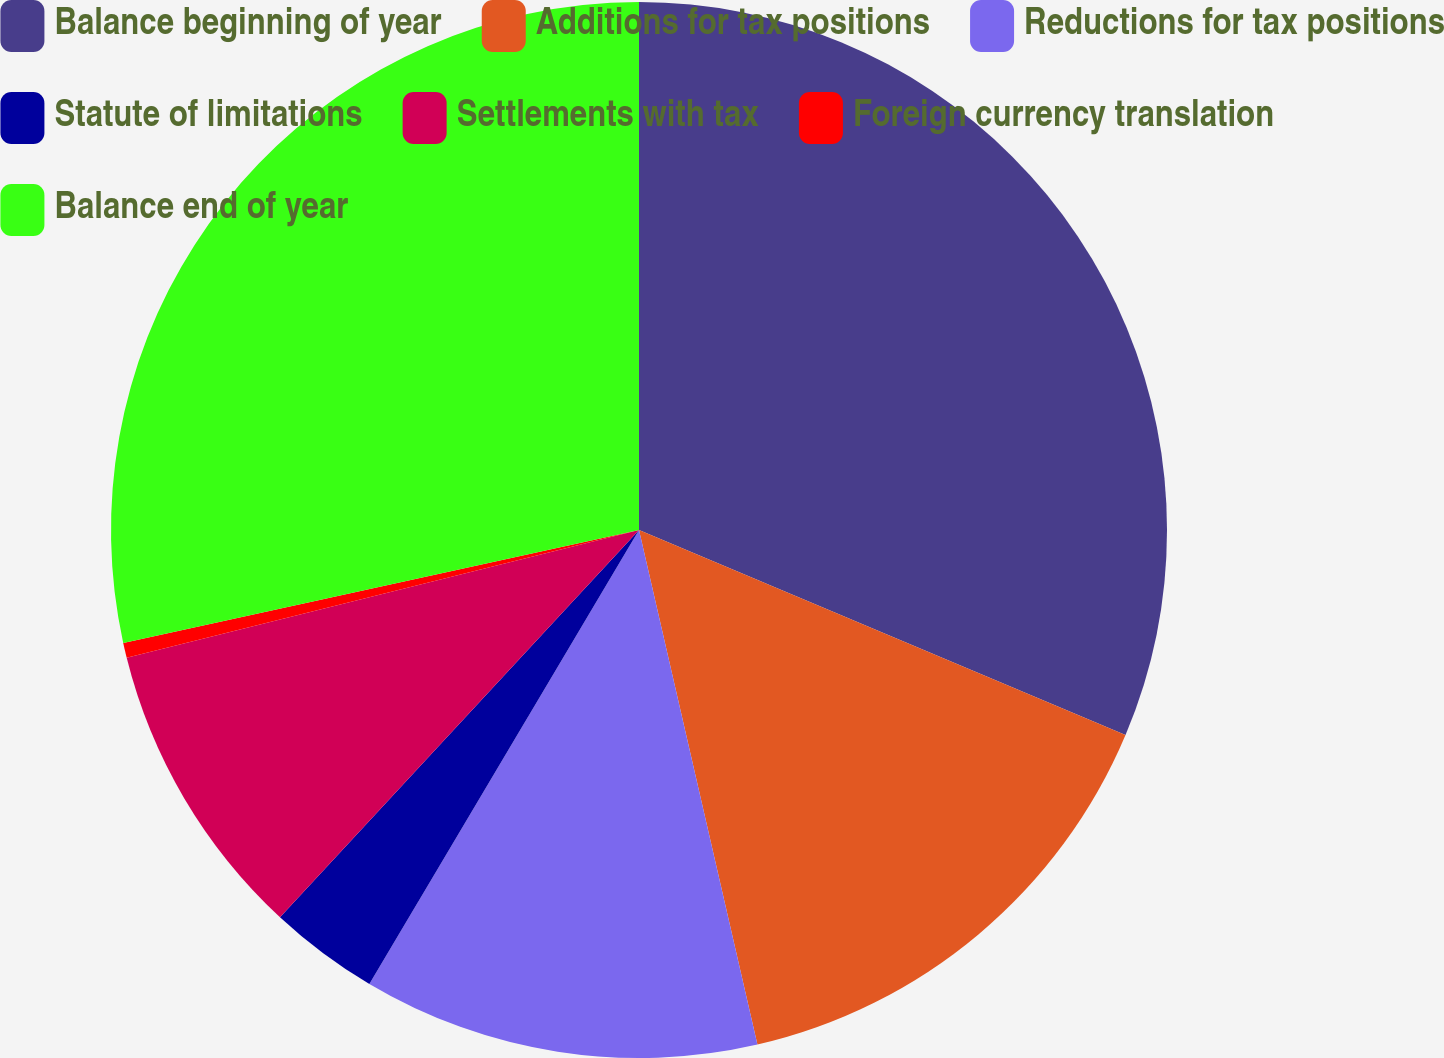Convert chart to OTSL. <chart><loc_0><loc_0><loc_500><loc_500><pie_chart><fcel>Balance beginning of year<fcel>Additions for tax positions<fcel>Reductions for tax positions<fcel>Statute of limitations<fcel>Settlements with tax<fcel>Foreign currency translation<fcel>Balance end of year<nl><fcel>31.35%<fcel>15.05%<fcel>12.13%<fcel>3.37%<fcel>9.21%<fcel>0.46%<fcel>28.43%<nl></chart> 